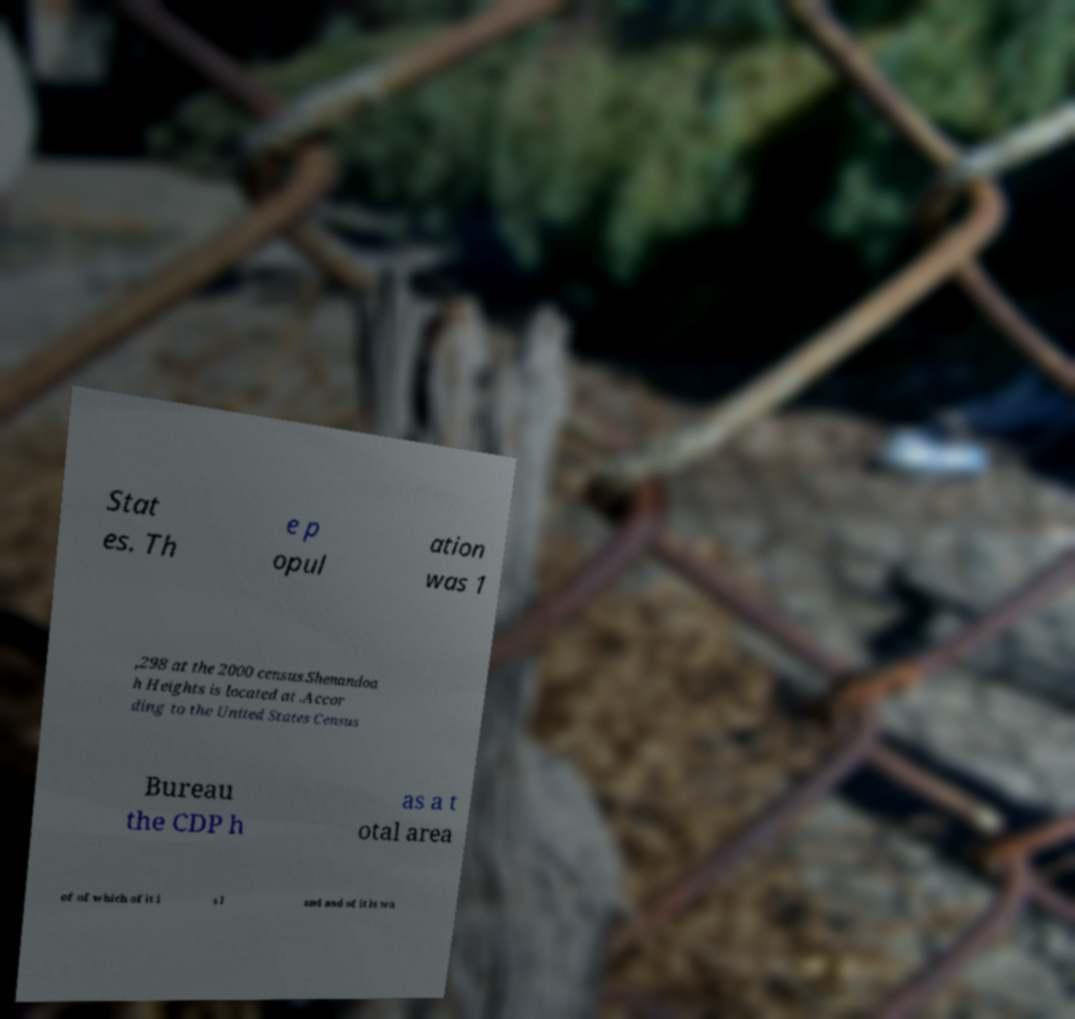There's text embedded in this image that I need extracted. Can you transcribe it verbatim? Stat es. Th e p opul ation was 1 ,298 at the 2000 census.Shenandoa h Heights is located at .Accor ding to the United States Census Bureau the CDP h as a t otal area of of which of it i s l and and of it is wa 